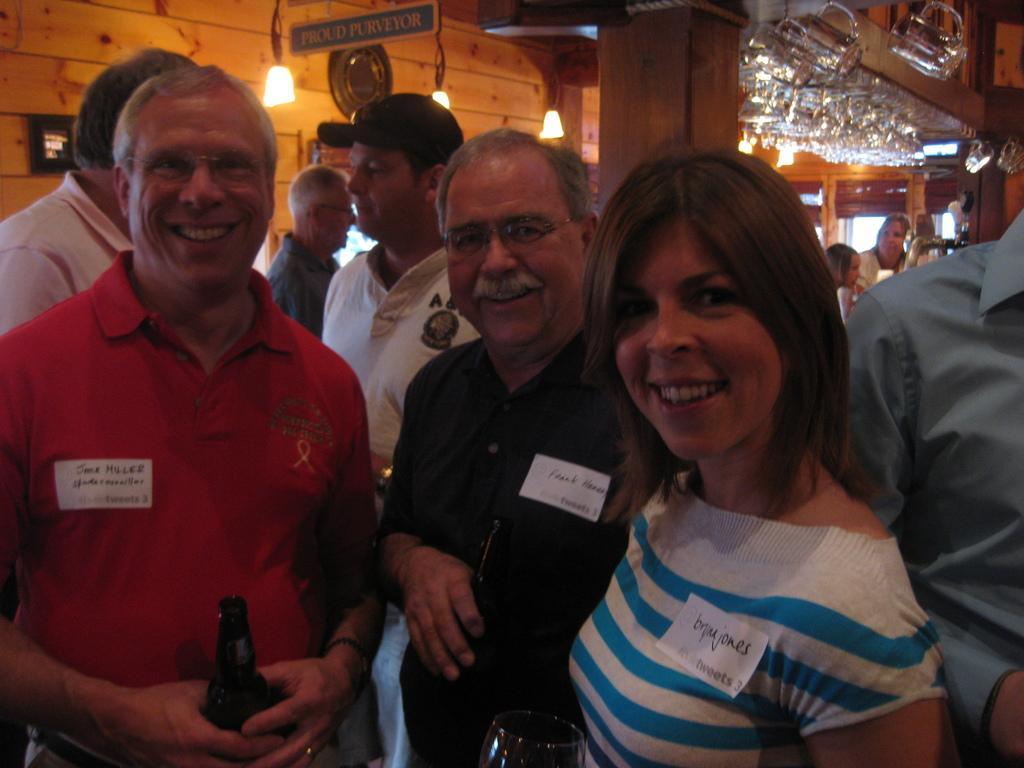Could you give a brief overview of what you see in this image? In this image, we can see some people standing, in the background, we can see a wooden pillar and there is a wooden wall, we can see a green board and we can see some lights. 